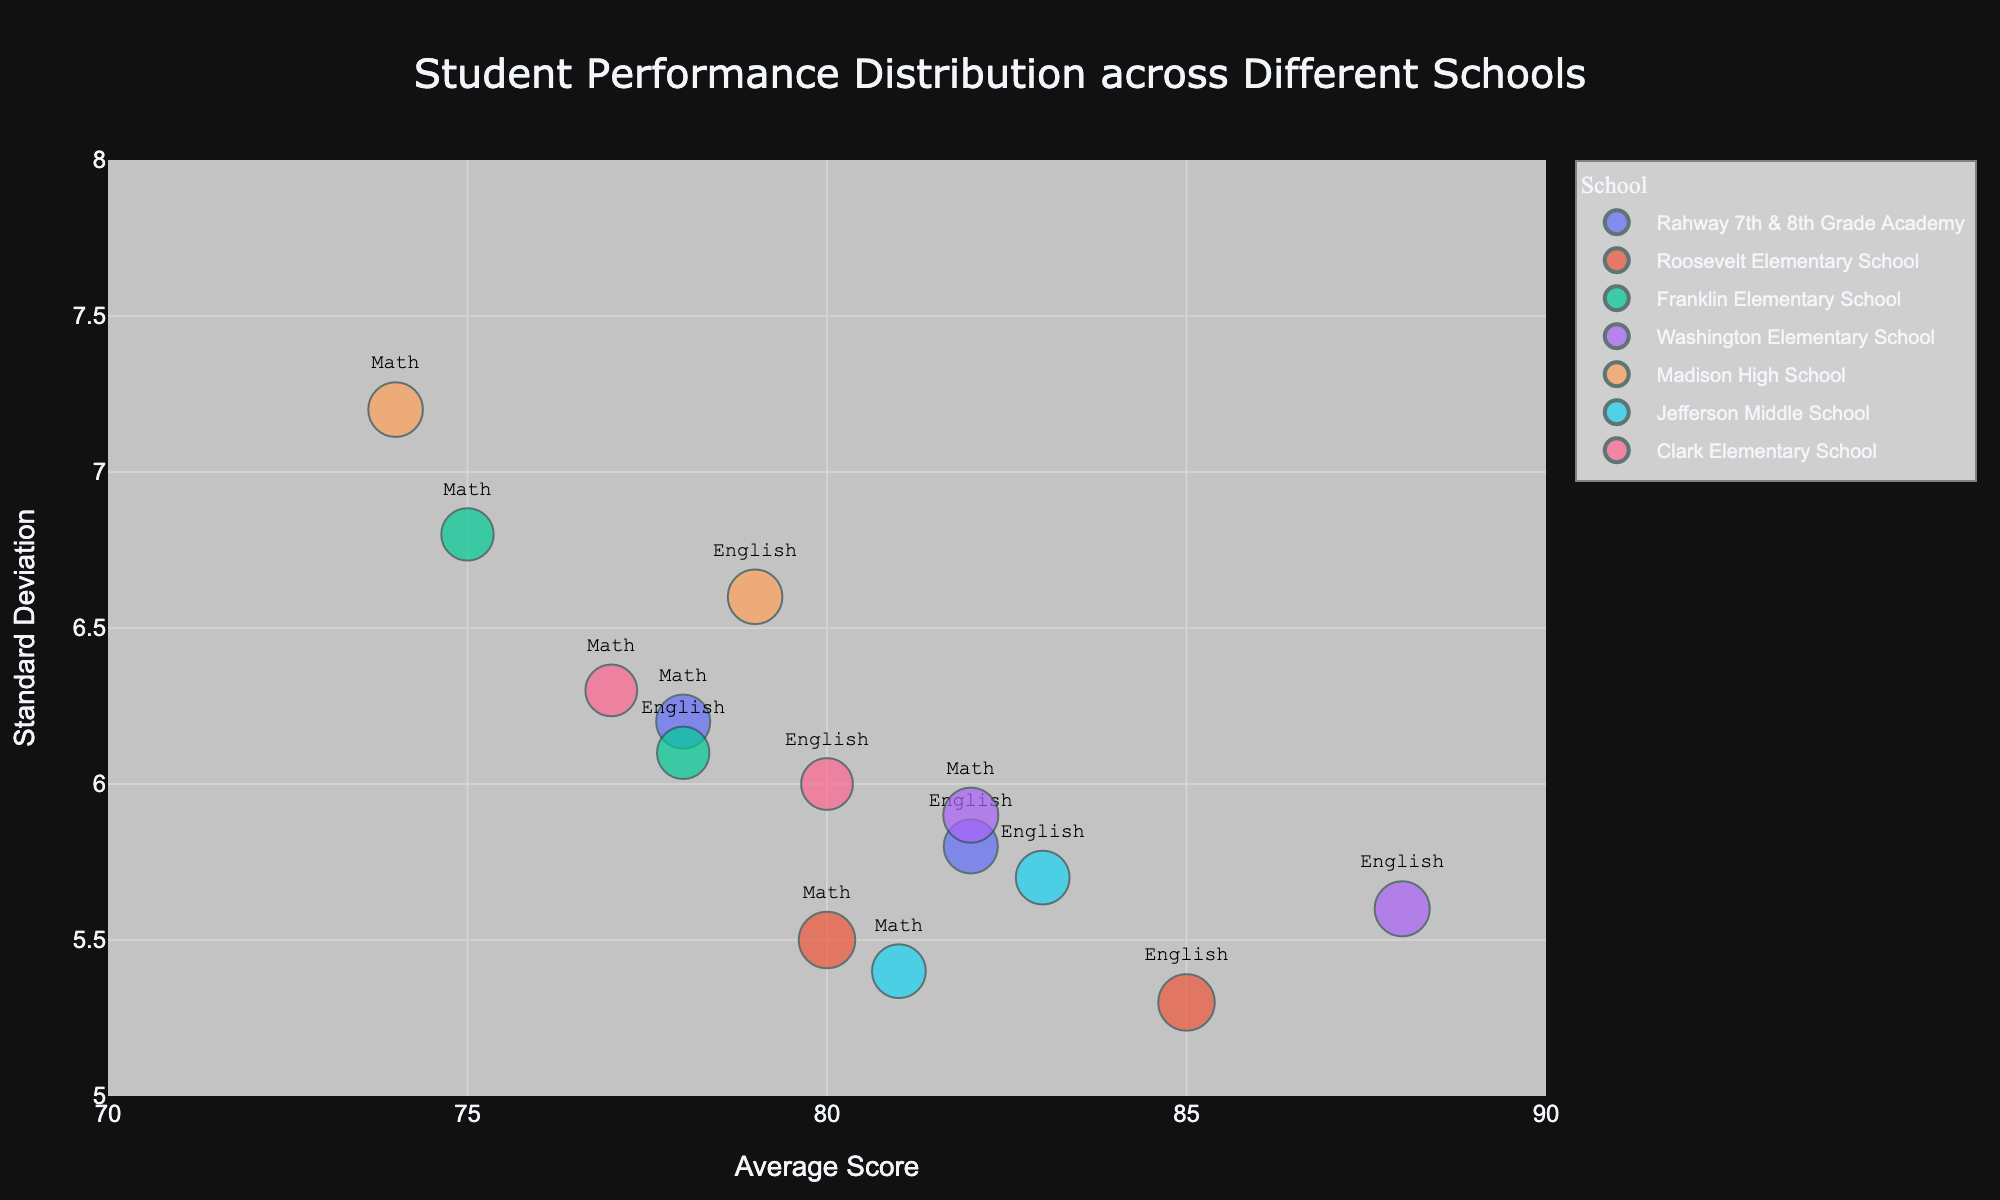What's the average math score at Rahway 7th & 8th Grade Academy? The bubble chart shows math scores as one axis, find Rahway 7th & 8th Grade Academy’s bubble for math and read the average score.
Answer: 78 How does the standard deviation of English scores at Washington Elementary School compare to Franklin Elementary School? Look for the standard deviation (y-axis) of the English scores for Washington Elementary and Franklin Elementary. Compare their y-values visually.
Answer: Lower at Washington Elementary Which school shows the highest average score in English? Locate the bubble with the highest x-axis value for English scores. The subject label will show it’s an English value.
Answer: Washington Elementary School How many students took math at Roosevelt Elementary School? The bubble size is a function of the number of students. Hover over the bubble for Roosevelt Elementary’s math score, and it will display the number of students.
Answer: 300 What is the range of standard deviations for math scores across all schools? Identify the lowest and highest y-axis values for all math bubbles. Subtract the lowest value from the highest.
Answer: 7.2 - 5.4 = 1.8 Which school has the smallest bubble for English scores? Find the smallest transparent bubble on the plot for the English subject. Hover to see the school name.
Answer: Clark Elementary School Are there any schools where math scores have a higher average than English scores? Compare the position of each school’s math and English bubbles on the x-axis. Find a school where the math bubble is further right than the English bubble.
Answer: No What is the total number of students who took English at all schools? Sum the number of students (displayed when hovering over bubbles) for English across all schools.
Answer: 250 + 300 + 220 + 270 + 245 + 210 = 1495 Which school has the most balanced performance between math and English? Look for a school where the math and English bubbles are close together in both average score (x-axis) and standard deviation (y-axis).
Answer: Jefferson Middle School Does Madison High School have a higher or lower average score in English compared to Clark Elementary School? Compare the x-values for English scores of Madison High School and Clark Elementary School.
Answer: Higher at Clark Elementary School 